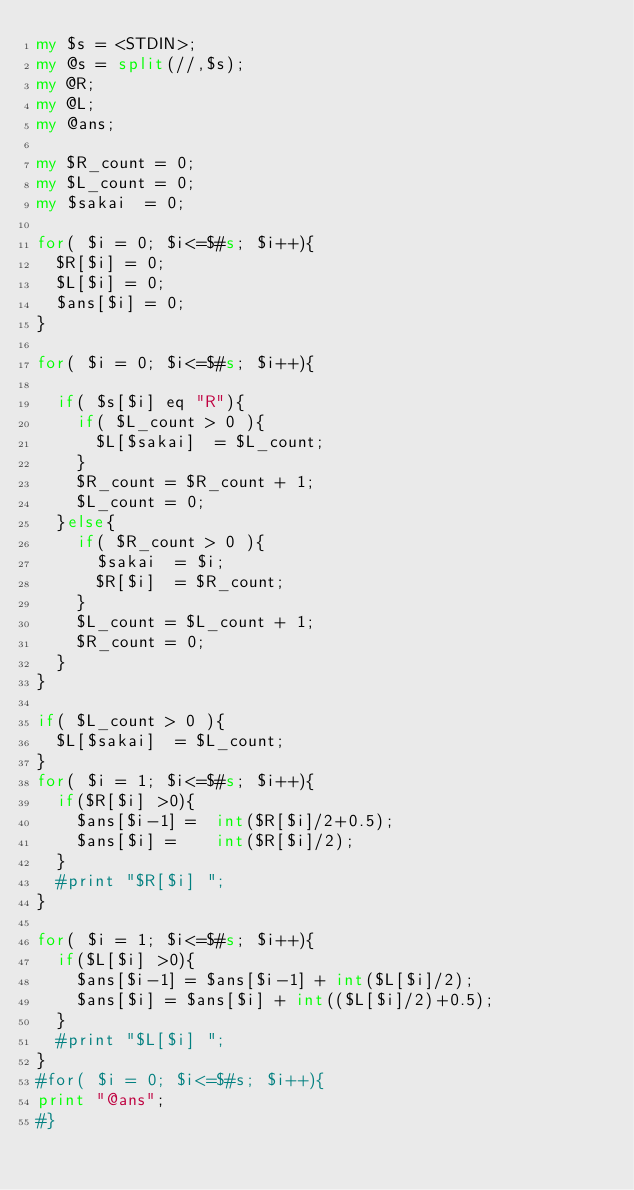<code> <loc_0><loc_0><loc_500><loc_500><_Perl_>my $s = <STDIN>;
my @s = split(//,$s);
my @R;
my @L;
my @ans;

my $R_count = 0;
my $L_count = 0;
my $sakai  = 0;

for( $i = 0; $i<=$#s; $i++){
  $R[$i] = 0;
  $L[$i] = 0;
  $ans[$i] = 0;
}

for( $i = 0; $i<=$#s; $i++){

  if( $s[$i] eq "R"){
    if( $L_count > 0 ){
      $L[$sakai]  = $L_count;
    }   
    $R_count = $R_count + 1;
    $L_count = 0;
  }else{
    if( $R_count > 0 ){
      $sakai  = $i;
      $R[$i]  = $R_count;
    }
    $L_count = $L_count + 1;
    $R_count = 0;
  }
}

if( $L_count > 0 ){
  $L[$sakai]  = $L_count;
}  
for( $i = 1; $i<=$#s; $i++){
  if($R[$i] >0){
    $ans[$i-1] =  int($R[$i]/2+0.5);
    $ans[$i] =    int($R[$i]/2);
  }
  #print "$R[$i] ";
}

for( $i = 1; $i<=$#s; $i++){
  if($L[$i] >0){
    $ans[$i-1] = $ans[$i-1] + int($L[$i]/2);
    $ans[$i] = $ans[$i] + int(($L[$i]/2)+0.5); 
  }
  #print "$L[$i] ";
}
#for( $i = 0; $i<=$#s; $i++){
print "@ans";
#}

</code> 